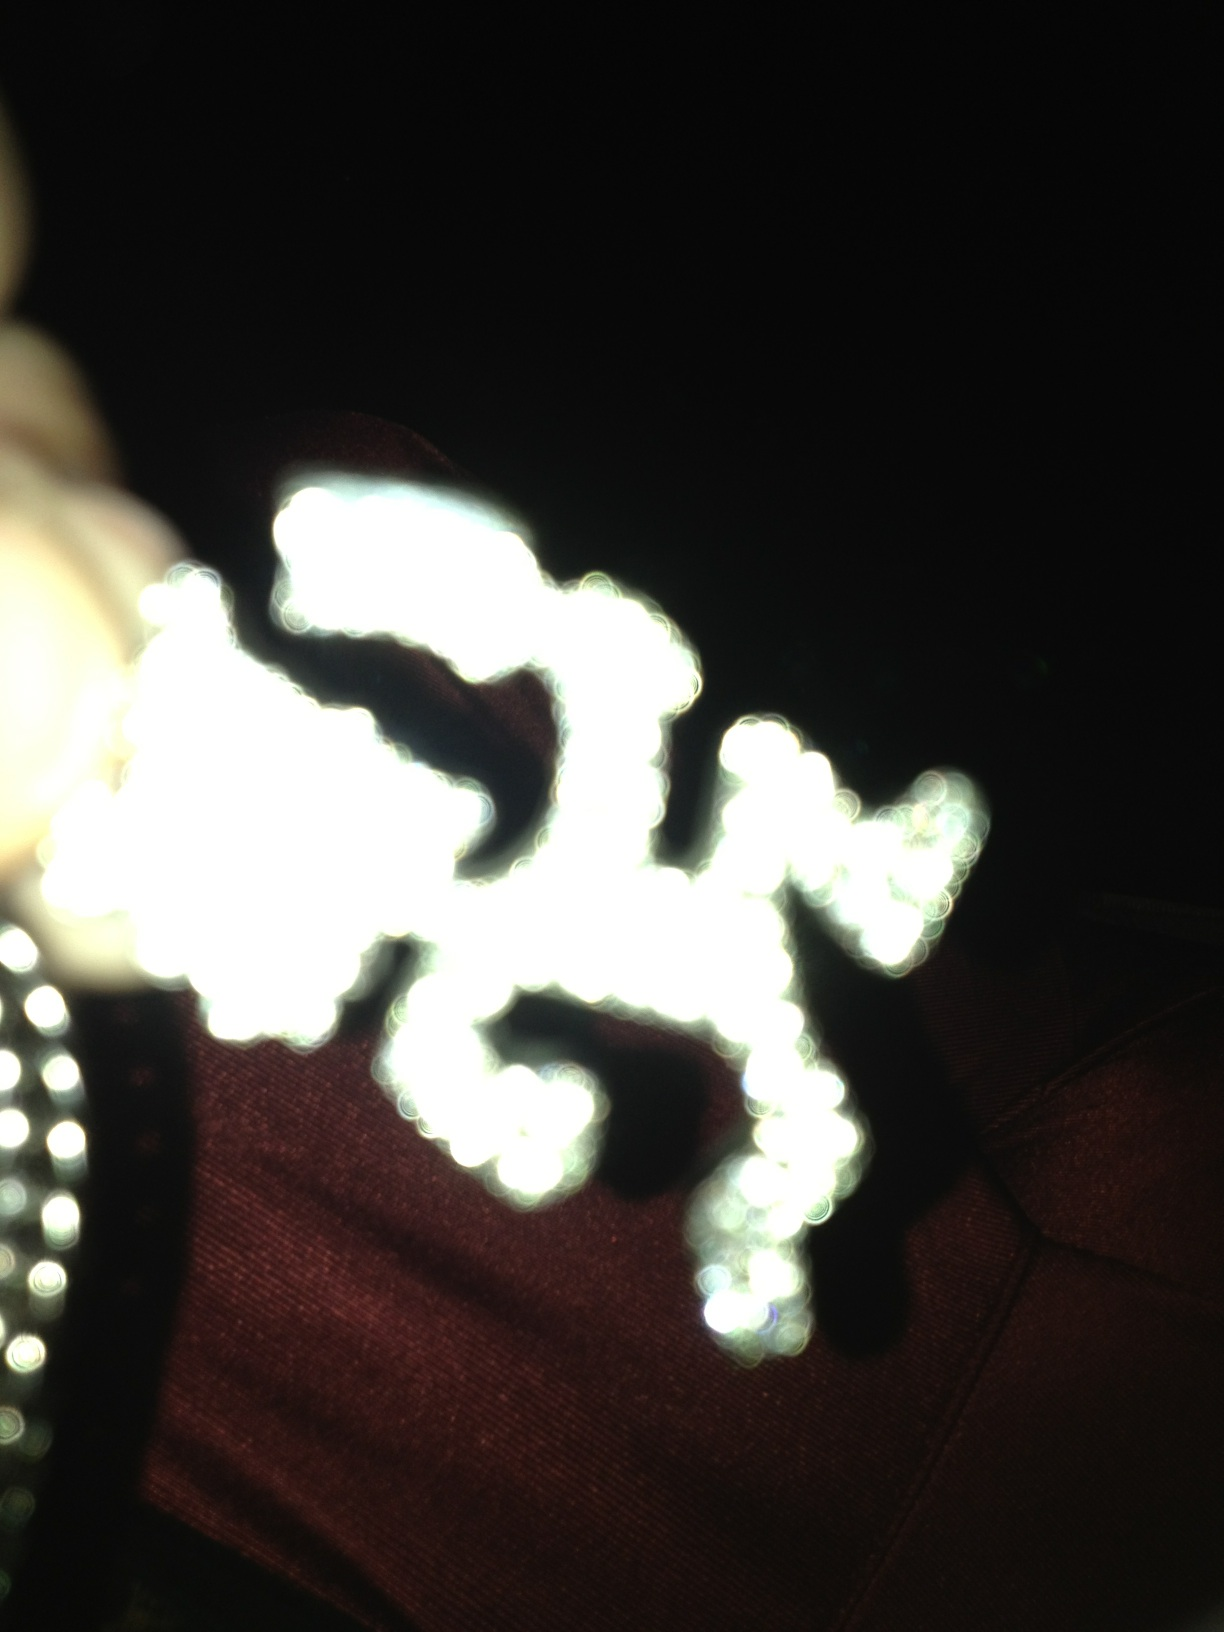Are the patterns or designs visible in this image suitable for any professional settings? From what little can be discerned in the blurred image, the bright, possibly intricate designs suggest a fancy or decorative element that might be best suited for personal or celebratory occasions rather than professional settings. Clarity on the item's actual appearance would aid in making a more definitive recommendation. 